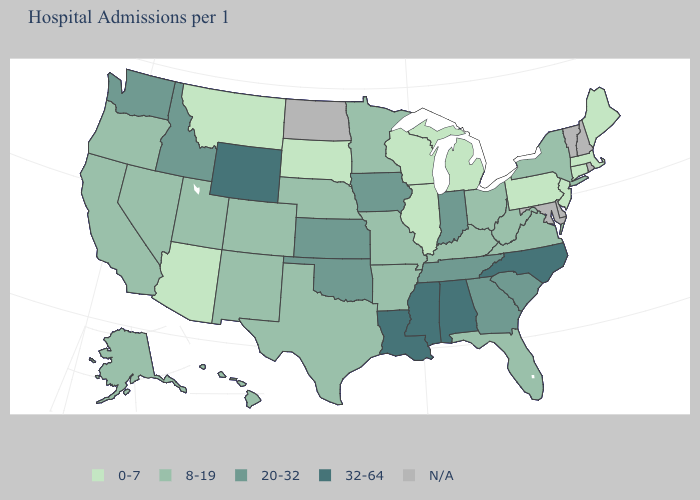Name the states that have a value in the range N/A?
Short answer required. Delaware, Maryland, New Hampshire, North Dakota, Rhode Island, Vermont. Which states have the lowest value in the USA?
Be succinct. Arizona, Connecticut, Illinois, Maine, Massachusetts, Michigan, Montana, New Jersey, Pennsylvania, South Dakota, Wisconsin. What is the value of Oregon?
Give a very brief answer. 8-19. Does Louisiana have the highest value in the USA?
Write a very short answer. Yes. What is the value of Mississippi?
Give a very brief answer. 32-64. Name the states that have a value in the range 20-32?
Write a very short answer. Georgia, Idaho, Indiana, Iowa, Kansas, Oklahoma, South Carolina, Tennessee, Washington. Among the states that border Nebraska , does Kansas have the highest value?
Quick response, please. No. Does Utah have the lowest value in the West?
Be succinct. No. What is the value of Maryland?
Give a very brief answer. N/A. Name the states that have a value in the range 0-7?
Write a very short answer. Arizona, Connecticut, Illinois, Maine, Massachusetts, Michigan, Montana, New Jersey, Pennsylvania, South Dakota, Wisconsin. Name the states that have a value in the range 20-32?
Be succinct. Georgia, Idaho, Indiana, Iowa, Kansas, Oklahoma, South Carolina, Tennessee, Washington. Does Pennsylvania have the lowest value in the USA?
Be succinct. Yes. What is the value of Arizona?
Concise answer only. 0-7. What is the lowest value in states that border Iowa?
Concise answer only. 0-7. 